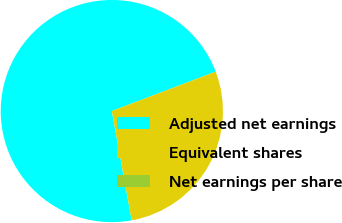<chart> <loc_0><loc_0><loc_500><loc_500><pie_chart><fcel>Adjusted net earnings<fcel>Equivalent shares<fcel>Net earnings per share<nl><fcel>72.09%<fcel>27.91%<fcel>0.0%<nl></chart> 